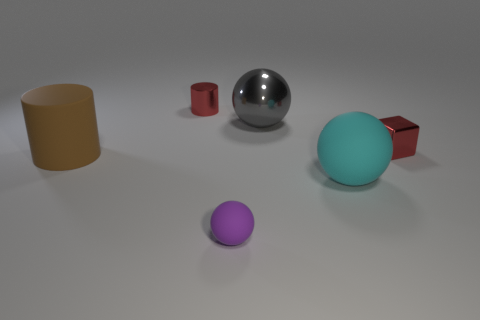Subtract all large balls. How many balls are left? 1 Add 1 large cyan spheres. How many objects exist? 7 Subtract all red balls. Subtract all gray cubes. How many balls are left? 3 Subtract all cylinders. How many objects are left? 4 Subtract all cyan matte things. Subtract all small red metallic objects. How many objects are left? 3 Add 4 large objects. How many large objects are left? 7 Add 6 tiny purple metal spheres. How many tiny purple metal spheres exist? 6 Subtract 0 red balls. How many objects are left? 6 